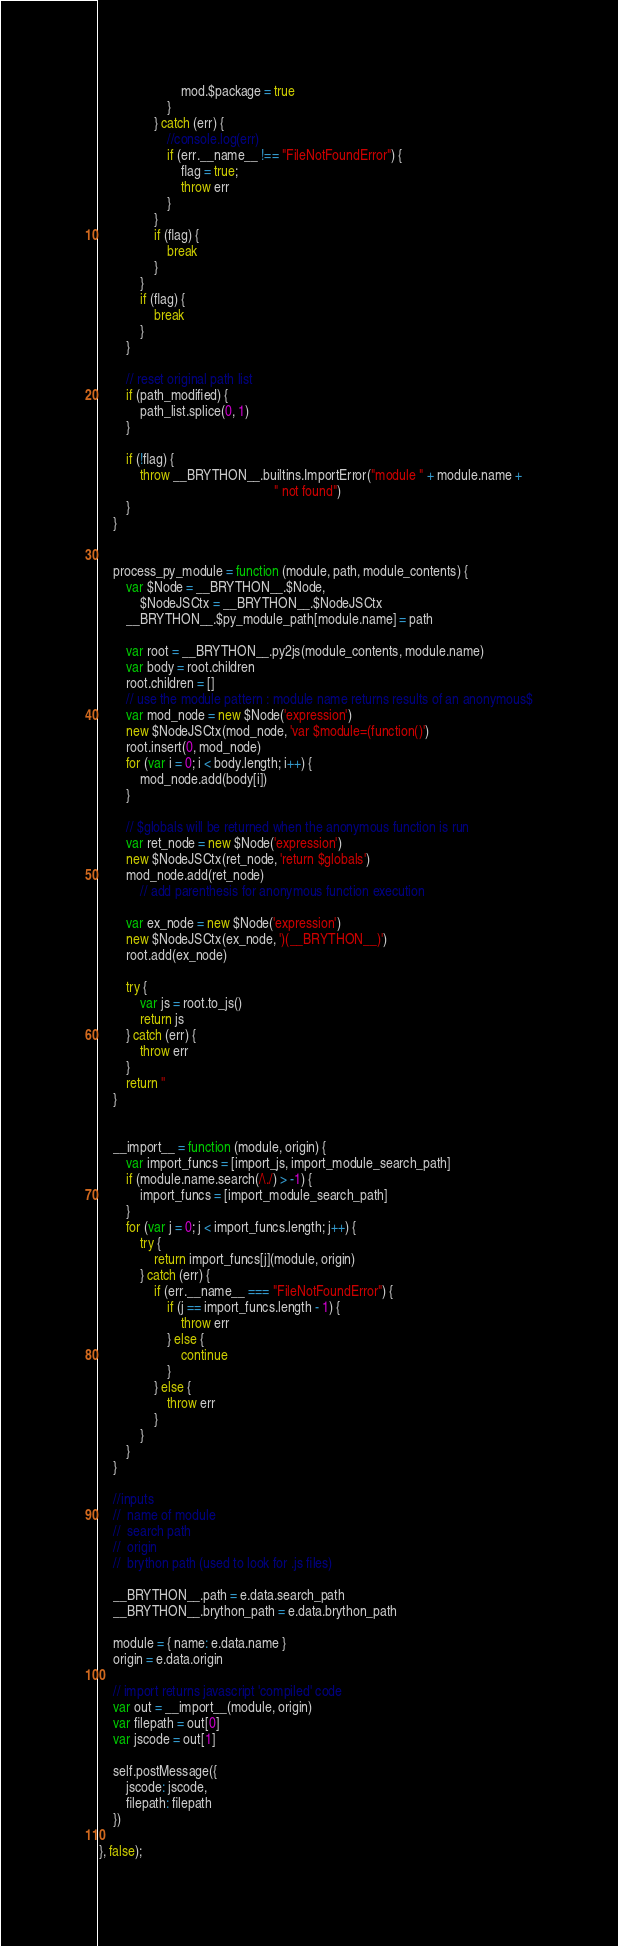<code> <loc_0><loc_0><loc_500><loc_500><_JavaScript_>                        mod.$package = true
                    }
                } catch (err) {
                    //console.log(err)
                    if (err.__name__ !== "FileNotFoundError") {
                        flag = true;
                        throw err
                    }
                }
                if (flag) {
                    break
                }
            }
            if (flag) {
                break
            }
        }

        // reset original path list
        if (path_modified) {
            path_list.splice(0, 1)
        }

        if (!flag) {
            throw __BRYTHON__.builtins.ImportError("module " + module.name +
                                                   " not found")
        }
    }


    process_py_module = function (module, path, module_contents) {
        var $Node = __BRYTHON__.$Node,
            $NodeJSCtx = __BRYTHON__.$NodeJSCtx
        __BRYTHON__.$py_module_path[module.name] = path

        var root = __BRYTHON__.py2js(module_contents, module.name)
        var body = root.children
        root.children = []
        // use the module pattern : module name returns results of an anonymous$
        var mod_node = new $Node('expression')
        new $NodeJSCtx(mod_node, 'var $module=(function()')
        root.insert(0, mod_node)
        for (var i = 0; i < body.length; i++) {
            mod_node.add(body[i])
        }

        // $globals will be returned when the anonymous function is run
        var ret_node = new $Node('expression')
        new $NodeJSCtx(ret_node, 'return $globals')
        mod_node.add(ret_node)
            // add parenthesis for anonymous function execution

        var ex_node = new $Node('expression')
        new $NodeJSCtx(ex_node, ')(__BRYTHON__)')
        root.add(ex_node)

        try {
            var js = root.to_js()
            return js
        } catch (err) {
            throw err
        }
        return ''
    }


    __import__ = function (module, origin) {
        var import_funcs = [import_js, import_module_search_path]
        if (module.name.search(/\./) > -1) {
            import_funcs = [import_module_search_path]
        }
        for (var j = 0; j < import_funcs.length; j++) {
            try {
                return import_funcs[j](module, origin)
            } catch (err) {
                if (err.__name__ === "FileNotFoundError") {
                    if (j == import_funcs.length - 1) {
                        throw err
                    } else {
                        continue
                    }
                } else {
                    throw err
                }
            }
        }
    }

    //inputs
    //  name of module
    //  search path
    //  origin
    //  brython path (used to look for .js files)

    __BRYTHON__.path = e.data.search_path
    __BRYTHON__.brython_path = e.data.brython_path

    module = { name: e.data.name }
    origin = e.data.origin

    // import returns javascript 'compiled' code
    var out = __import__(module, origin)
    var filepath = out[0]
    var jscode = out[1]

    self.postMessage({
        jscode: jscode,
        filepath: filepath
    })

}, false);
</code> 